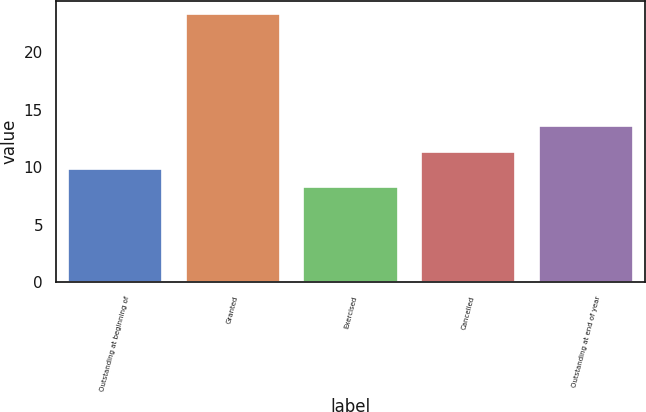Convert chart. <chart><loc_0><loc_0><loc_500><loc_500><bar_chart><fcel>Outstanding at beginning of<fcel>Granted<fcel>Exercised<fcel>Cancelled<fcel>Outstanding at end of year<nl><fcel>9.82<fcel>23.33<fcel>8.32<fcel>11.32<fcel>13.61<nl></chart> 